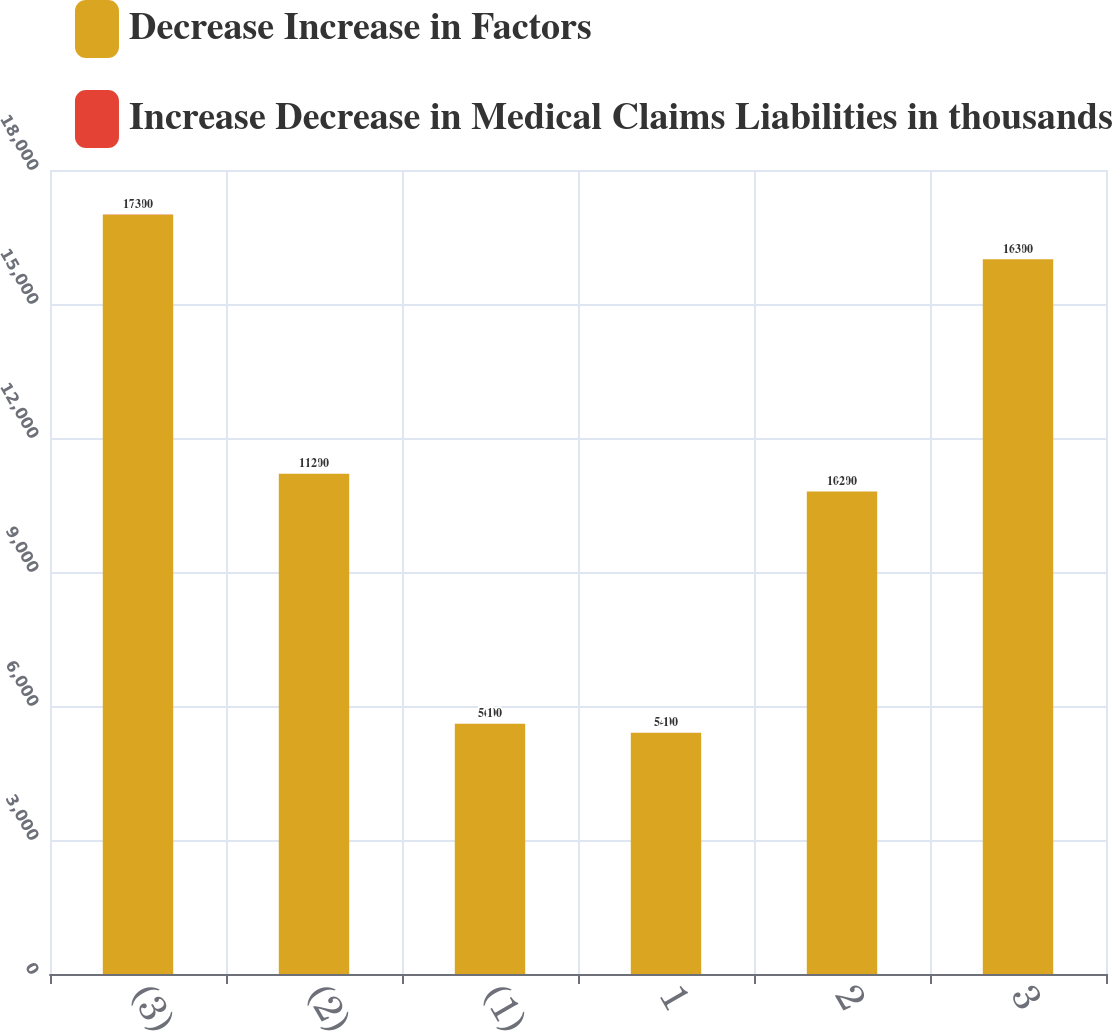<chart> <loc_0><loc_0><loc_500><loc_500><stacked_bar_chart><ecel><fcel>(3)<fcel>(2)<fcel>(1)<fcel>1<fcel>2<fcel>3<nl><fcel>Decrease Increase in Factors<fcel>17000<fcel>11200<fcel>5600<fcel>5400<fcel>10800<fcel>16000<nl><fcel>Increase Decrease in Medical Claims Liabilities in thousands<fcel>3<fcel>2<fcel>1<fcel>1<fcel>2<fcel>3<nl></chart> 